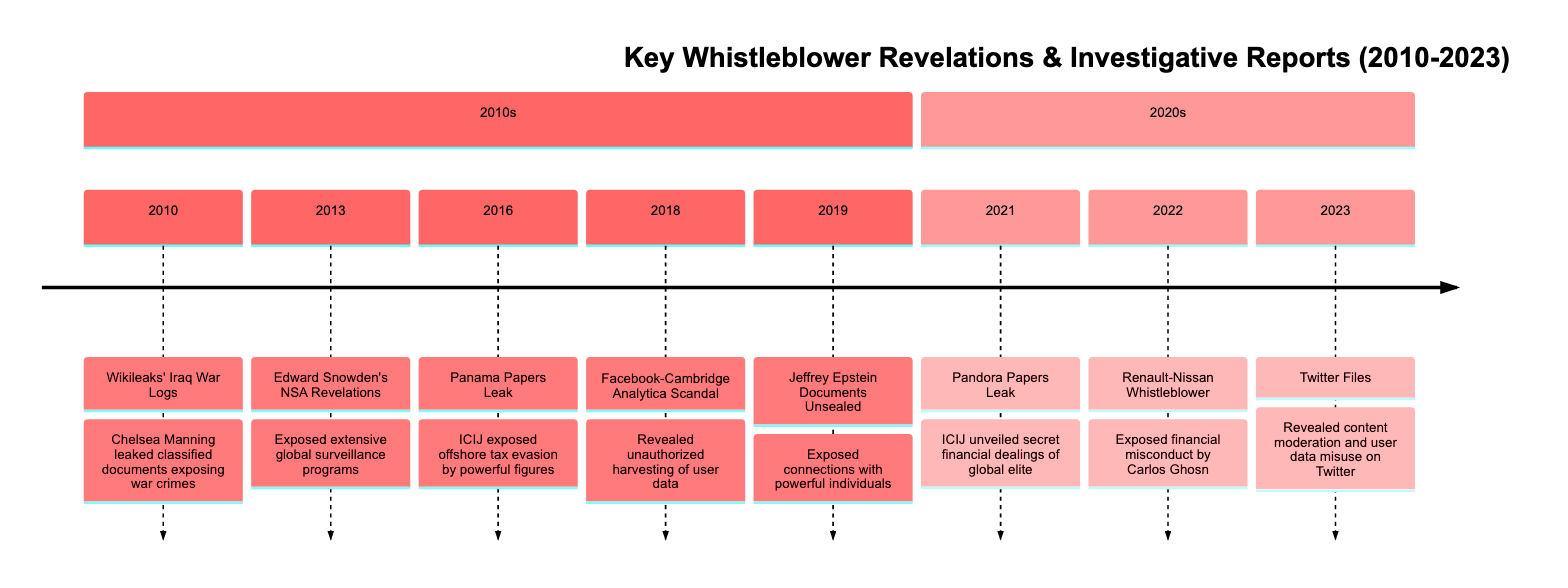What event is linked to the year 2013? The diagram states that in 2013, Edward Snowden’s NSA Revelations occurred, which is explicitly mentioned next to that year.
Answer: Edward Snowden’s NSA Revelations What major scandal was revealed in 2016? The diagram indicates that the Panama Papers Leak was the significant event in 2016, detailing the exposed offshore tax evasion by powerful figures.
Answer: Panama Papers Leak How many events are documented in the timeline? By counting each listed event in the timeline, we find there are eight distinct events mentioned from 2010 to 2023.
Answer: 8 Which year saw the release of the Twitter Files? The timeline clearly states that the Twitter Files were released in 2023, as it is specified beside that year.
Answer: 2023 What is the key focus of the 2018 discovery? In 2018, the focus was on the Facebook-Cambridge Analytica Scandal, which is detailed in the description for that year.
Answer: Facebook-Cambridge Analytica Scandal Which revelations challenged the narrative of accountability in technology? The description for the 2018 event highlights the Facebook-Cambridge Analytica Scandal as the critical investigation challenging the notion of accountability in tech companies.
Answer: Facebook-Cambridge Analytica Scandal What was the result of the Renault-Nissan whistleblower in 2022? The timeline shows that the Renault-Nissan Whistleblower exposed financial misconduct by Carlos Ghosn, leading to significant repercussions.
Answer: Exposed financial misconduct by Carlos Ghosn Which year had the earliest event documented? The diagram lists the first event, the Wikileaks' Iraq War Logs, in the year 2010, making it the earliest documented revelation in the timeline.
Answer: 2010 What was a key outcome of the Pandora Papers Leak in 2021? The description notes that the Pandora Papers Leak unveiled the secret financial dealings of the global elite, showcasing the ways business moguls evade taxation.
Answer: Secret financial dealings of global elite 